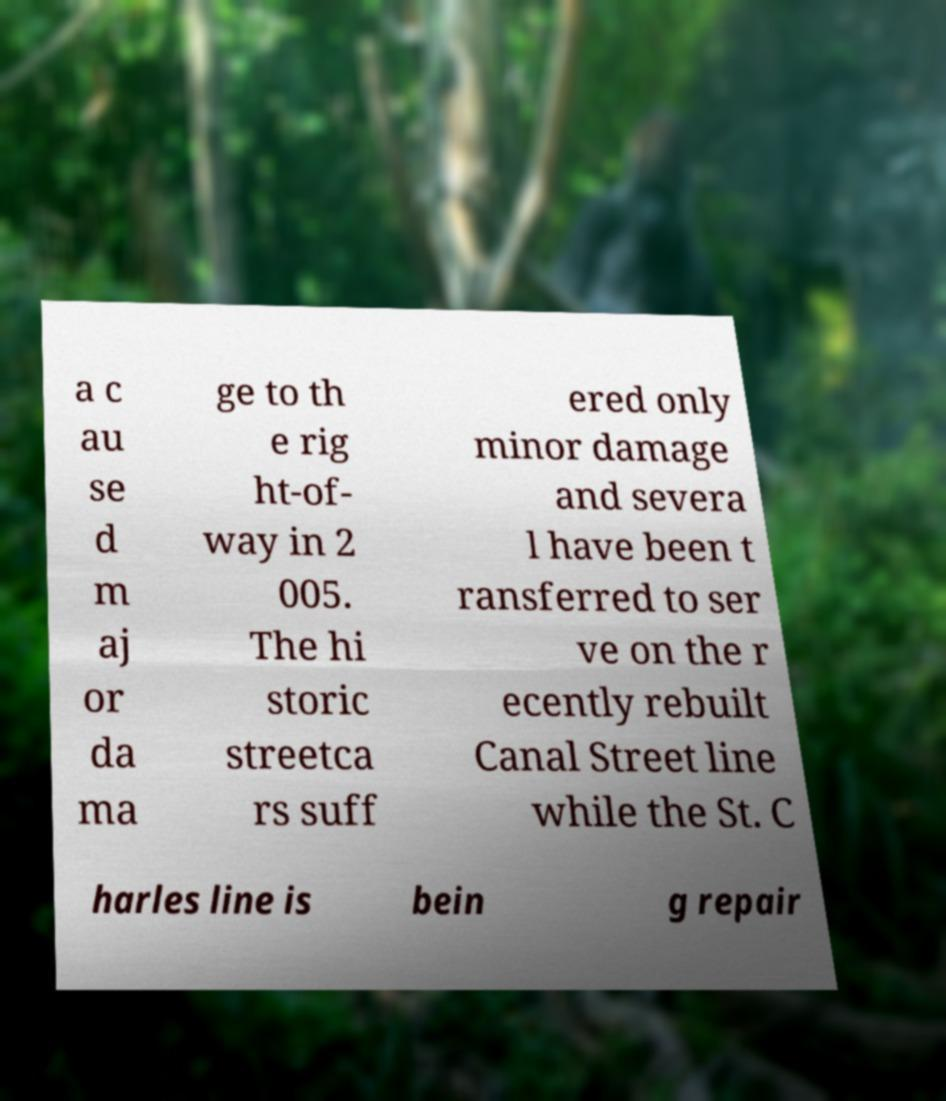Please identify and transcribe the text found in this image. a c au se d m aj or da ma ge to th e rig ht-of- way in 2 005. The hi storic streetca rs suff ered only minor damage and severa l have been t ransferred to ser ve on the r ecently rebuilt Canal Street line while the St. C harles line is bein g repair 